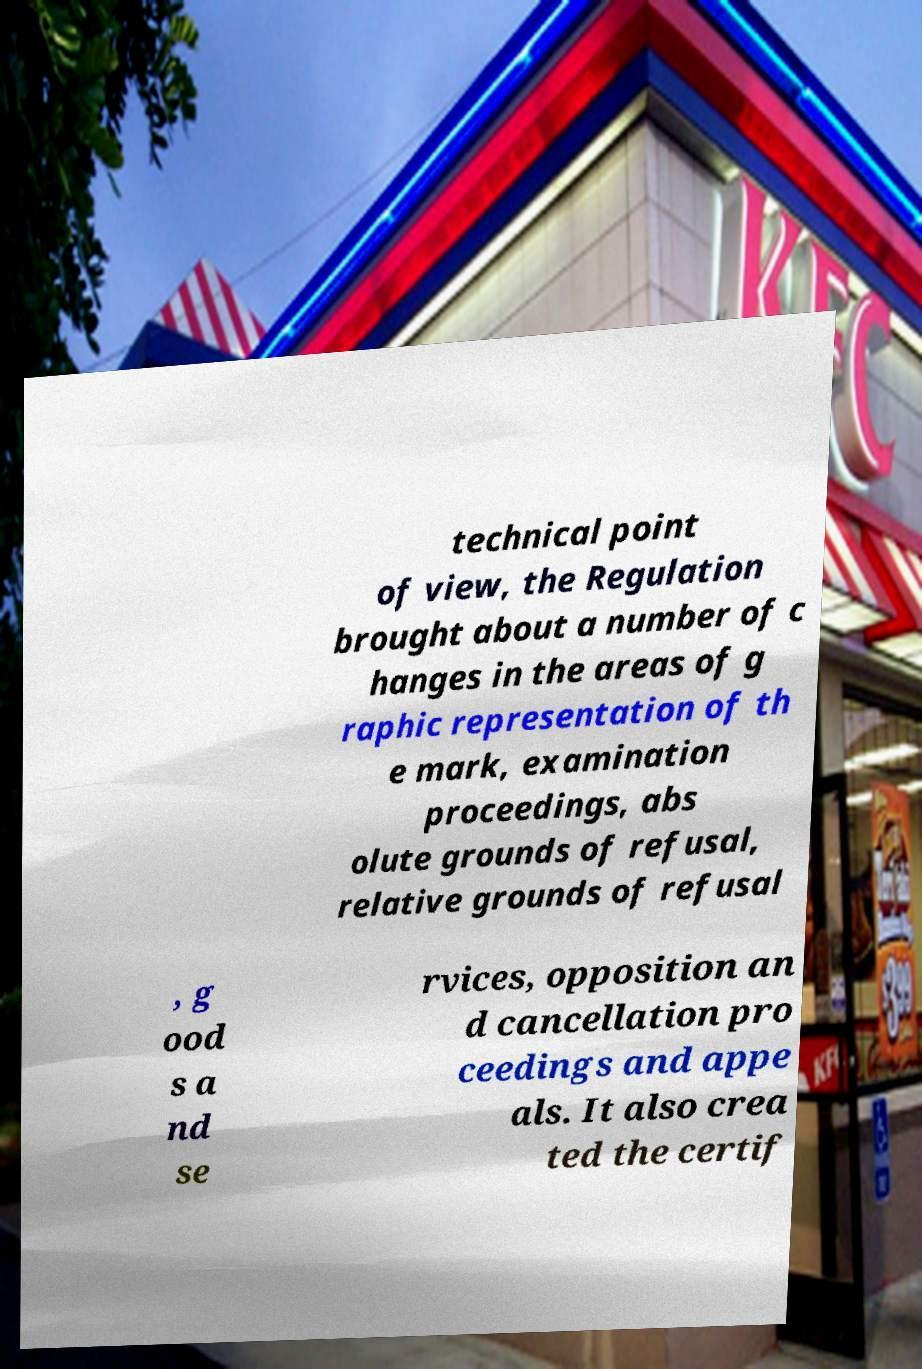Please read and relay the text visible in this image. What does it say? technical point of view, the Regulation brought about a number of c hanges in the areas of g raphic representation of th e mark, examination proceedings, abs olute grounds of refusal, relative grounds of refusal , g ood s a nd se rvices, opposition an d cancellation pro ceedings and appe als. It also crea ted the certif 